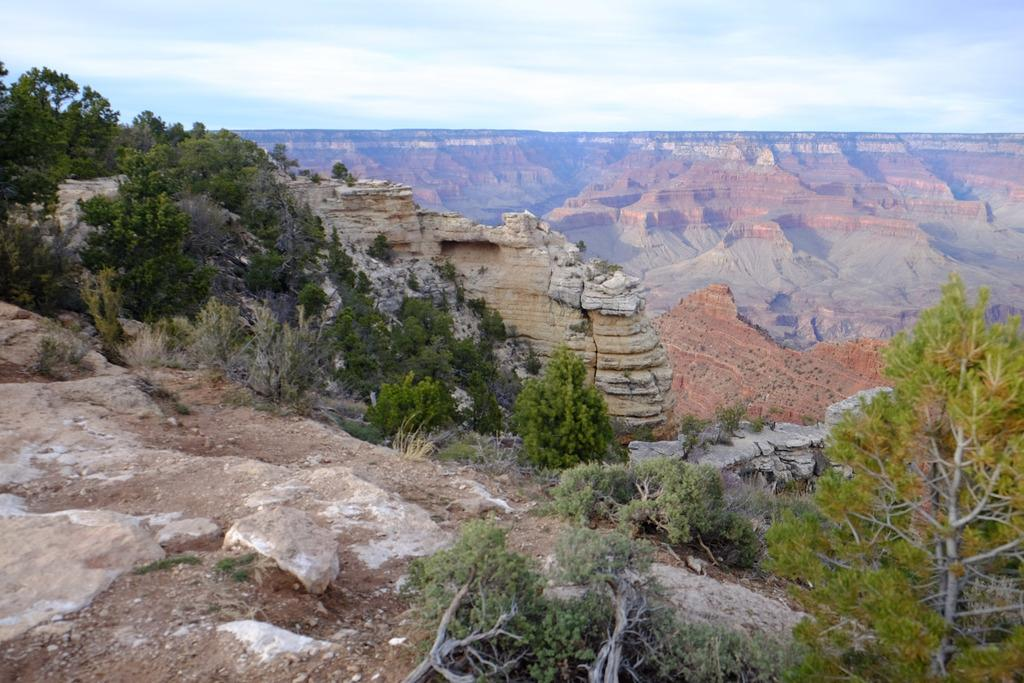What type of natural landform can be seen in the image? There are mountains in the image. What type of vegetation is present in the image? There are trees and plants in the image. What type of geological feature can be seen in the image? There are rocks in the image. What part of the sky is visible in the image? The sky is visible at the bottom of the image. Where can you find the lunchroom in the image? There is no lunchroom present in the image; it features natural landscapes. Can you touch the mountains in the image? The mountains in the image are not physically present, so you cannot touch them. 